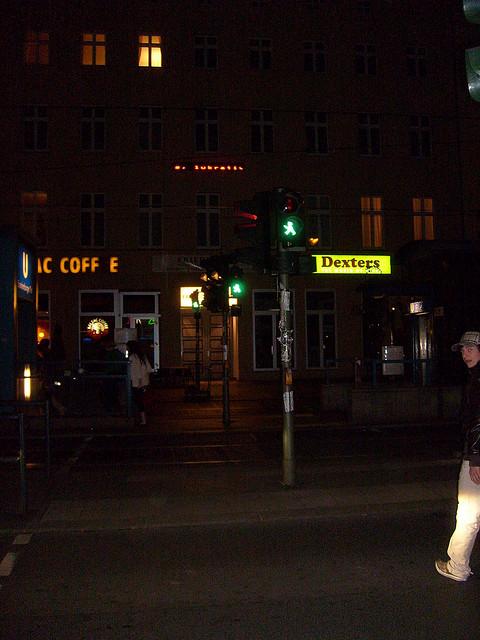Is it night or daytime?
Concise answer only. Night. What is the name of the business with the yellow sign?
Be succinct. Dexter's. Why is it too deep?
Short answer required. It's not. 